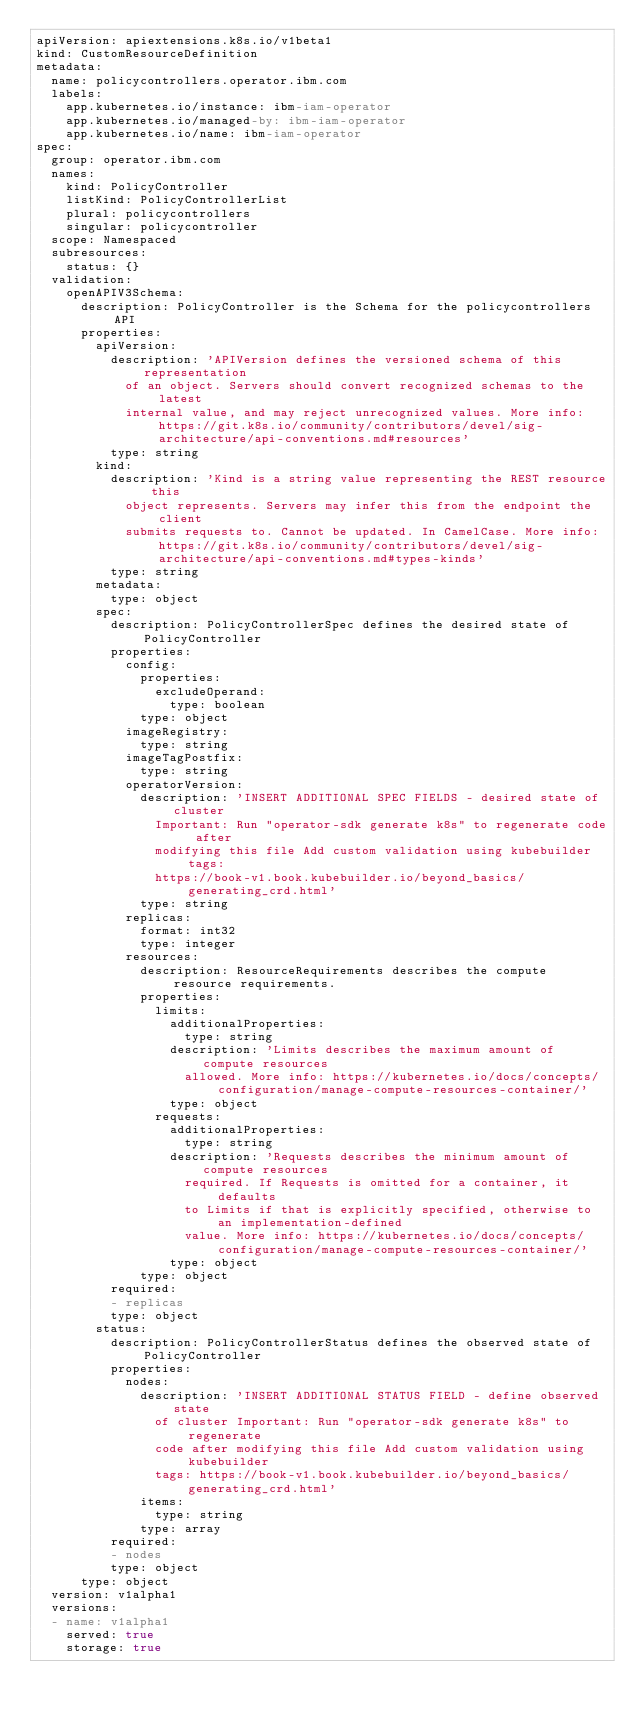<code> <loc_0><loc_0><loc_500><loc_500><_YAML_>apiVersion: apiextensions.k8s.io/v1beta1
kind: CustomResourceDefinition
metadata:
  name: policycontrollers.operator.ibm.com
  labels:
    app.kubernetes.io/instance: ibm-iam-operator
    app.kubernetes.io/managed-by: ibm-iam-operator
    app.kubernetes.io/name: ibm-iam-operator
spec:
  group: operator.ibm.com
  names:
    kind: PolicyController
    listKind: PolicyControllerList
    plural: policycontrollers
    singular: policycontroller
  scope: Namespaced
  subresources:
    status: {}
  validation:
    openAPIV3Schema:
      description: PolicyController is the Schema for the policycontrollers API
      properties:
        apiVersion:
          description: 'APIVersion defines the versioned schema of this representation
            of an object. Servers should convert recognized schemas to the latest
            internal value, and may reject unrecognized values. More info: https://git.k8s.io/community/contributors/devel/sig-architecture/api-conventions.md#resources'
          type: string
        kind:
          description: 'Kind is a string value representing the REST resource this
            object represents. Servers may infer this from the endpoint the client
            submits requests to. Cannot be updated. In CamelCase. More info: https://git.k8s.io/community/contributors/devel/sig-architecture/api-conventions.md#types-kinds'
          type: string
        metadata:
          type: object
        spec:
          description: PolicyControllerSpec defines the desired state of PolicyController
          properties:
            config:
              properties:
                excludeOperand:
                  type: boolean
              type: object
            imageRegistry:
              type: string
            imageTagPostfix:
              type: string
            operatorVersion:
              description: 'INSERT ADDITIONAL SPEC FIELDS - desired state of cluster
                Important: Run "operator-sdk generate k8s" to regenerate code after
                modifying this file Add custom validation using kubebuilder tags:
                https://book-v1.book.kubebuilder.io/beyond_basics/generating_crd.html'
              type: string
            replicas:
              format: int32
              type: integer
            resources:
              description: ResourceRequirements describes the compute resource requirements.
              properties:
                limits:
                  additionalProperties:
                    type: string
                  description: 'Limits describes the maximum amount of compute resources
                    allowed. More info: https://kubernetes.io/docs/concepts/configuration/manage-compute-resources-container/'
                  type: object
                requests:
                  additionalProperties:
                    type: string
                  description: 'Requests describes the minimum amount of compute resources
                    required. If Requests is omitted for a container, it defaults
                    to Limits if that is explicitly specified, otherwise to an implementation-defined
                    value. More info: https://kubernetes.io/docs/concepts/configuration/manage-compute-resources-container/'
                  type: object
              type: object
          required:
          - replicas
          type: object
        status:
          description: PolicyControllerStatus defines the observed state of PolicyController
          properties:
            nodes:
              description: 'INSERT ADDITIONAL STATUS FIELD - define observed state
                of cluster Important: Run "operator-sdk generate k8s" to regenerate
                code after modifying this file Add custom validation using kubebuilder
                tags: https://book-v1.book.kubebuilder.io/beyond_basics/generating_crd.html'
              items:
                type: string
              type: array
          required:
          - nodes
          type: object
      type: object
  version: v1alpha1
  versions:
  - name: v1alpha1
    served: true
    storage: true
</code> 